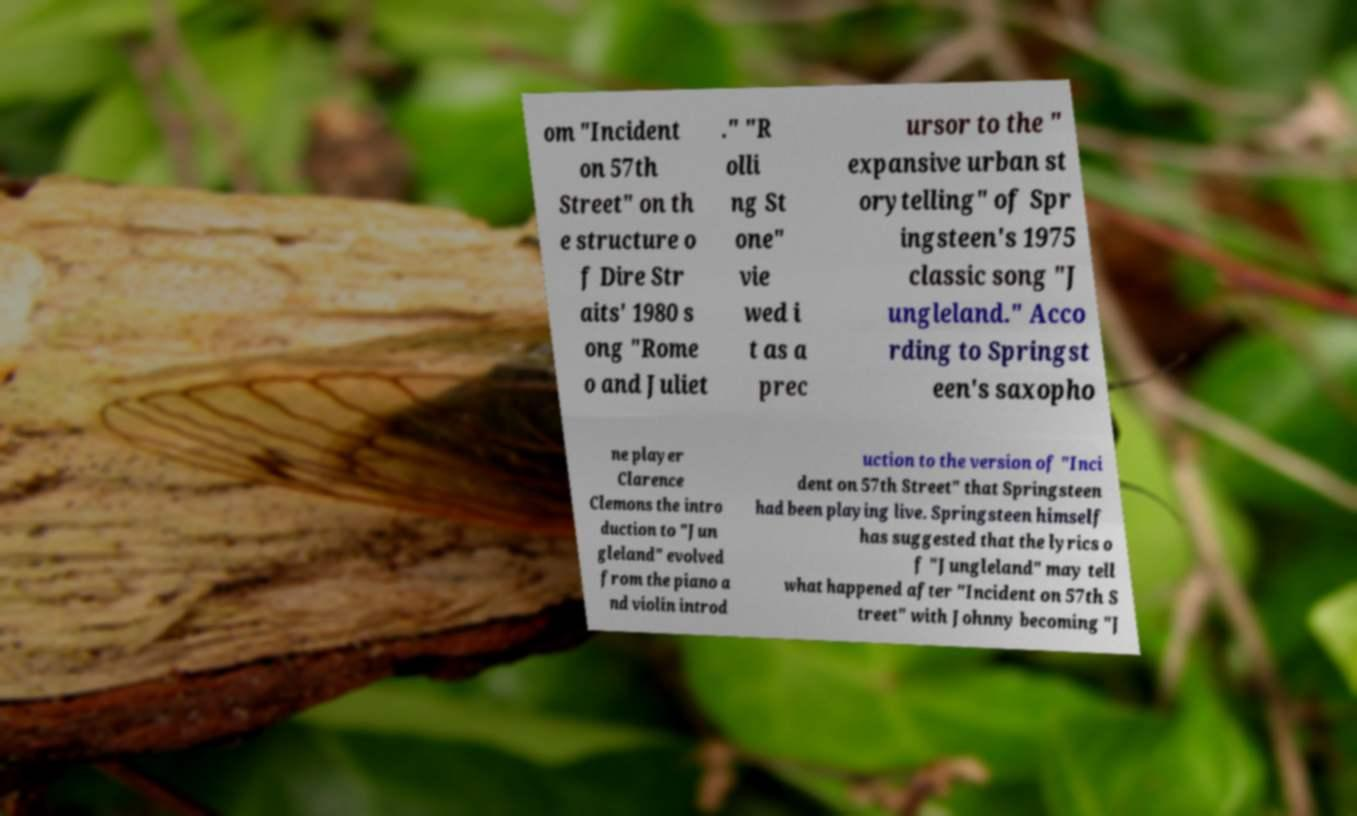Could you assist in decoding the text presented in this image and type it out clearly? om "Incident on 57th Street" on th e structure o f Dire Str aits' 1980 s ong "Rome o and Juliet ." "R olli ng St one" vie wed i t as a prec ursor to the " expansive urban st orytelling" of Spr ingsteen's 1975 classic song "J ungleland." Acco rding to Springst een's saxopho ne player Clarence Clemons the intro duction to "Jun gleland" evolved from the piano a nd violin introd uction to the version of "Inci dent on 57th Street" that Springsteen had been playing live. Springsteen himself has suggested that the lyrics o f "Jungleland" may tell what happened after "Incident on 57th S treet" with Johnny becoming "J 